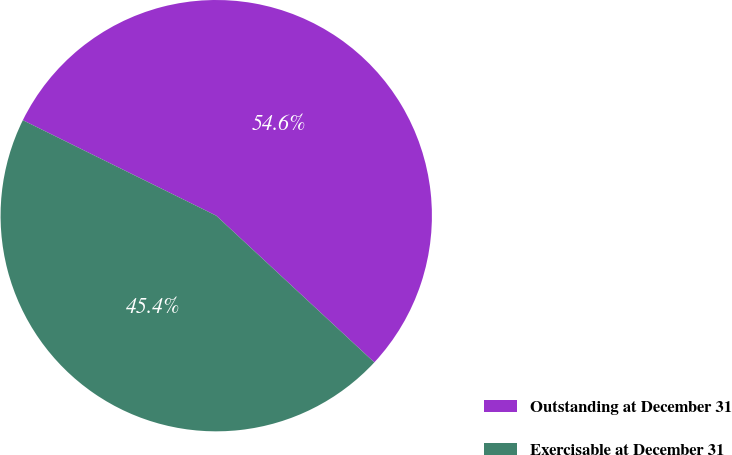Convert chart to OTSL. <chart><loc_0><loc_0><loc_500><loc_500><pie_chart><fcel>Outstanding at December 31<fcel>Exercisable at December 31<nl><fcel>54.61%<fcel>45.39%<nl></chart> 